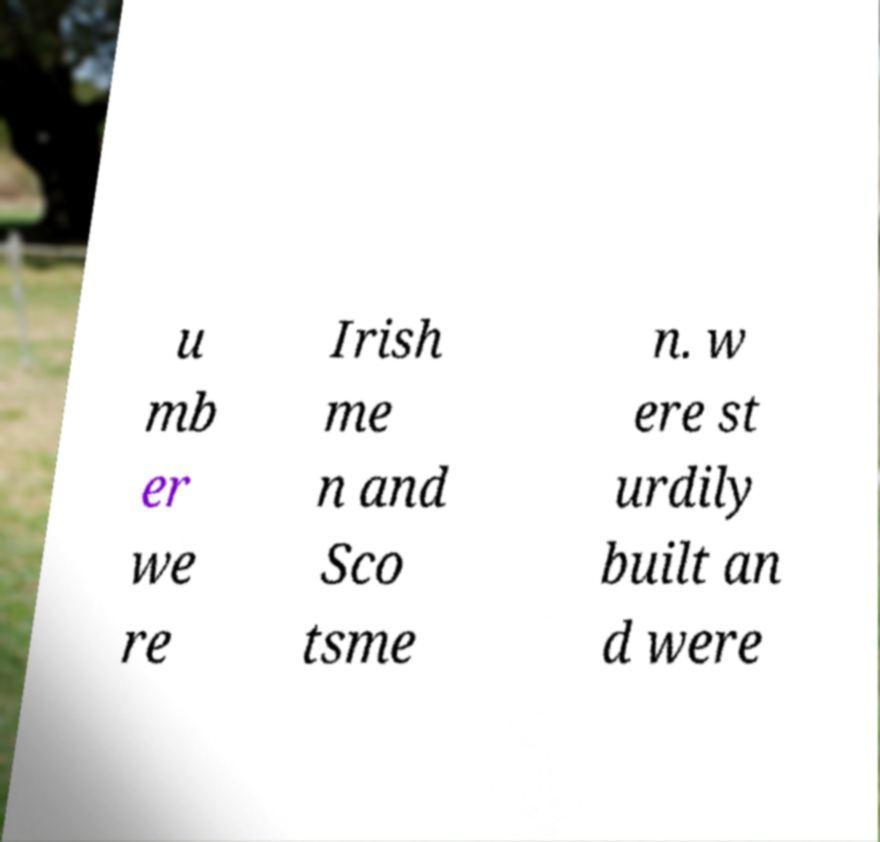There's text embedded in this image that I need extracted. Can you transcribe it verbatim? u mb er we re Irish me n and Sco tsme n. w ere st urdily built an d were 